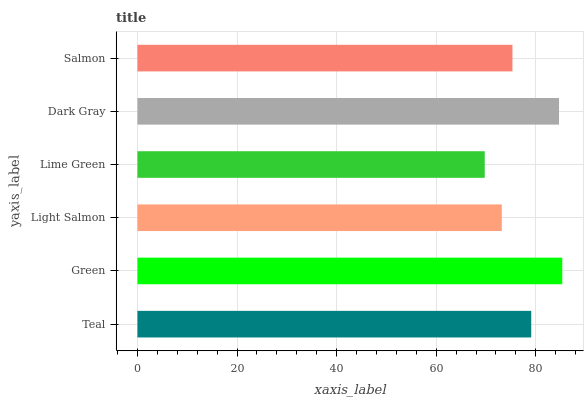Is Lime Green the minimum?
Answer yes or no. Yes. Is Green the maximum?
Answer yes or no. Yes. Is Light Salmon the minimum?
Answer yes or no. No. Is Light Salmon the maximum?
Answer yes or no. No. Is Green greater than Light Salmon?
Answer yes or no. Yes. Is Light Salmon less than Green?
Answer yes or no. Yes. Is Light Salmon greater than Green?
Answer yes or no. No. Is Green less than Light Salmon?
Answer yes or no. No. Is Teal the high median?
Answer yes or no. Yes. Is Salmon the low median?
Answer yes or no. Yes. Is Salmon the high median?
Answer yes or no. No. Is Green the low median?
Answer yes or no. No. 